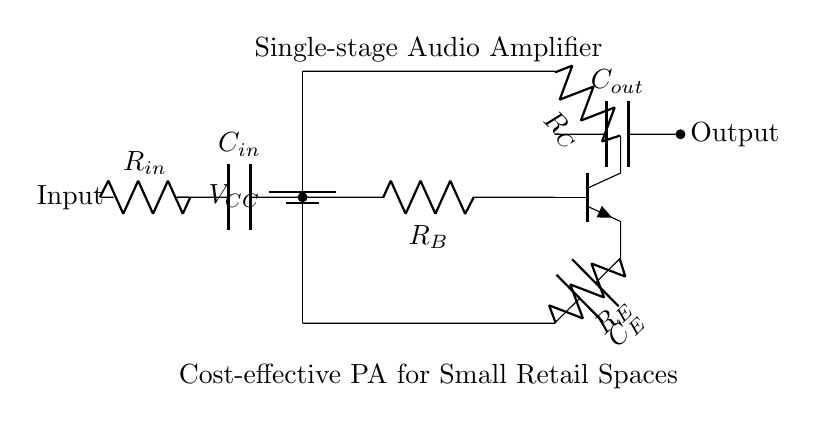What is the type of transistor used in this amplifier? The circuit diagram shows an npn transistor, which is indicated by the symbol and label within the diagram. Npn transistors are commonly used in audio amplifiers for their ability to amplify current.
Answer: npn What is the function of capacitor C_in? C_in serves as an input coupling capacitor, allowing AC signals to pass while blocking DC components from the input, ensuring that the transistor only processes the audio signal.
Answer: coupling What is the purpose of resistor R_E? R_E is the emitter resistor, which provides stability to the amplifier by helping set the biasing point of the transistor and providing negative feedback, thereby improving linearity and reducing distortion.
Answer: stability What is the configuration of this amplifier? This single-stage amplifier is likely in a common emitter configuration, as indicated by the arrangement of the transistor and its connections, which allows for both voltage amplification and phase inversion.
Answer: common emitter What is the typical voltage of V_CC assumed for small PA systems? For cost-effective small PA systems, a common assumption for V_CC would be around 12 volts, which is sufficient for providing bias to the transistor while being safe and manageable for small businesses.
Answer: 12 volts What does capacitor C_out do in the circuit? C_out is the output coupling capacitor that blocks any DC component from reaching the load (such as speakers) while allowing the amplified AC audio signal to pass through, ensuring that only audio is transmitted to the next stage or speaker system.
Answer: output coupling 